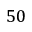<formula> <loc_0><loc_0><loc_500><loc_500>5 0</formula> 